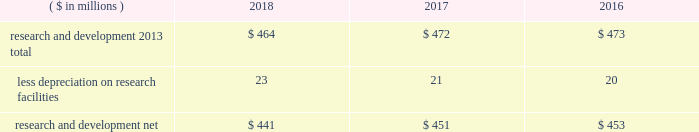52 2018 ppg annual report and 10-k 1 .
Summary of significant accounting policies principles of consolidation the accompanying consolidated financial statements include the accounts of ppg industries , inc .
( 201cppg 201d or the 201ccompany 201d ) and all subsidiaries , both u.s .
And non-u.s. , that it controls .
Ppg owns more than 50% ( 50 % ) of the voting stock of most of the subsidiaries that it controls .
For those consolidated subsidiaries in which the company 2019s ownership is less than 100% ( 100 % ) , the outside shareholders 2019 interests are shown as noncontrolling interests .
Investments in companies in which ppg owns 20% ( 20 % ) to 50% ( 50 % ) of the voting stock and has the ability to exercise significant influence over operating and financial policies of the investee are accounted for using the equity method of accounting .
As a result , ppg 2019s share of income or losses from such equity affiliates is included in the consolidated statement of income and ppg 2019s share of these companies 2019 shareholders 2019 equity is included in investments on the consolidated balance sheet .
Transactions between ppg and its subsidiaries are eliminated in consolidation .
Use of estimates in the preparation of financial statements the preparation of financial statements in conformity with u.s .
Generally accepted accounting principles requires management to make estimates and assumptions that affect the reported amounts of assets and liabilities and the disclosure of contingent assets and liabilities at the date of the financial statements , as well as the reported amounts of income and expenses during the reporting period .
Such estimates also include the fair value of assets acquired and liabilities assumed resulting from the allocation of the purchase price related to business combinations consummated .
Actual outcomes could differ from those estimates .
Revenue recognition revenue is recognized as performance obligations with the customer are satisfied , at an amount that is determined to be collectible .
For the sale of products , this generally occurs at the point in time when control of the company 2019s products transfers to the customer based on the agreed upon shipping terms .
Shipping and handling costs amounts billed to customers for shipping and handling are reported in net sales in the consolidated statement of income .
Shipping and handling costs incurred by the company for the delivery of goods to customers are included in cost of sales , exclusive of depreciation and amortization in the consolidated statement of income .
Selling , general and administrative costs amounts presented in selling , general and administrative in the consolidated statement of income are comprised of selling , customer service , distribution and advertising costs , as well as the costs of providing corporate-wide functional support in such areas as finance , law , human resources and planning .
Distribution costs pertain to the movement and storage of finished goods inventory at company-owned and leased warehouses and other distribution facilities .
Advertising costs advertising costs are expensed as incurred and totaled $ 280 million , $ 313 million and $ 322 million in 2018 , 2017 and 2016 , respectively .
Research and development research and development costs , which consist primarily of employee related costs , are charged to expense as incurred. .
Legal costs legal costs , primarily include costs associated with acquisition and divestiture transactions , general litigation , environmental regulation compliance , patent and trademark protection and other general corporate purposes , are charged to expense as incurred .
Income taxes income taxes are accounted for under the asset and liability method .
Deferred tax assets and liabilities are recognized for the future tax consequences attributable to operating losses and tax credit carryforwards as well as differences between the financial statement carrying amounts of existing assets and liabilities and their respective tax bases .
The effect on deferred notes to the consolidated financial statements .
What was the change in research and development net in millions from 2016 to 2017? 
Computations: (451 - 453)
Answer: -2.0. 